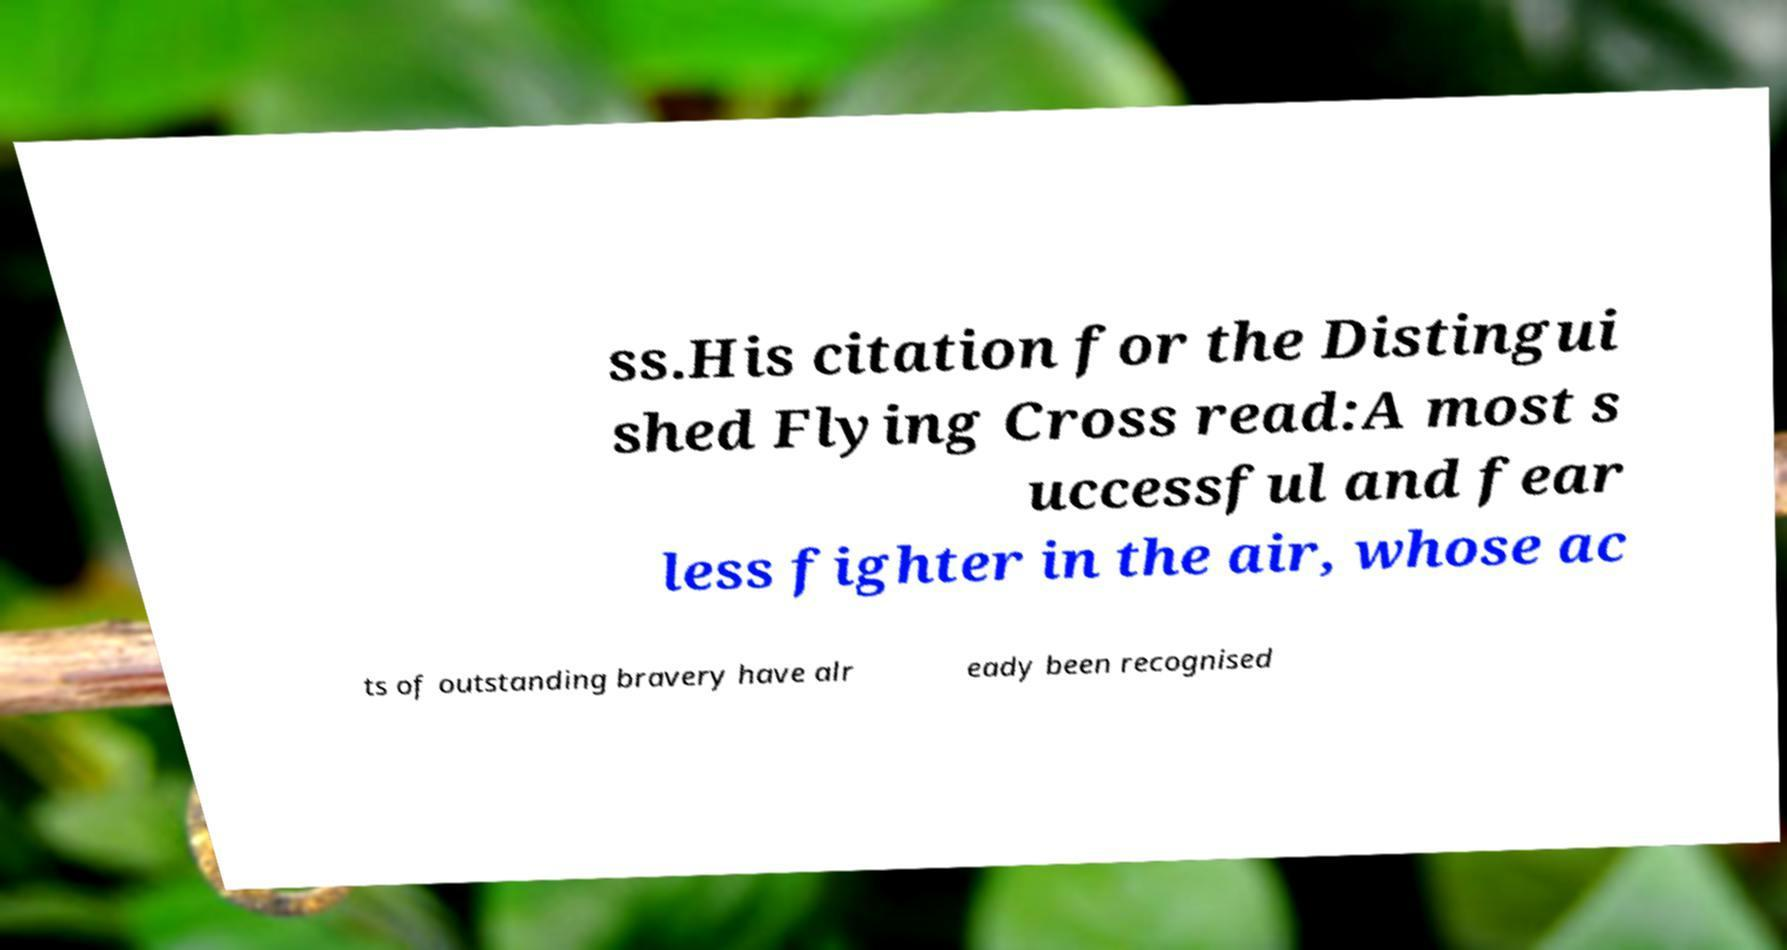Can you accurately transcribe the text from the provided image for me? ss.His citation for the Distingui shed Flying Cross read:A most s uccessful and fear less fighter in the air, whose ac ts of outstanding bravery have alr eady been recognised 